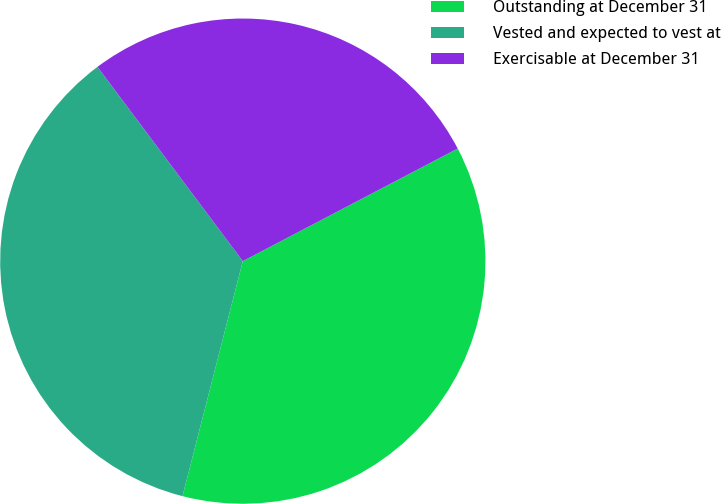Convert chart. <chart><loc_0><loc_0><loc_500><loc_500><pie_chart><fcel>Outstanding at December 31<fcel>Vested and expected to vest at<fcel>Exercisable at December 31<nl><fcel>36.68%<fcel>35.78%<fcel>27.54%<nl></chart> 